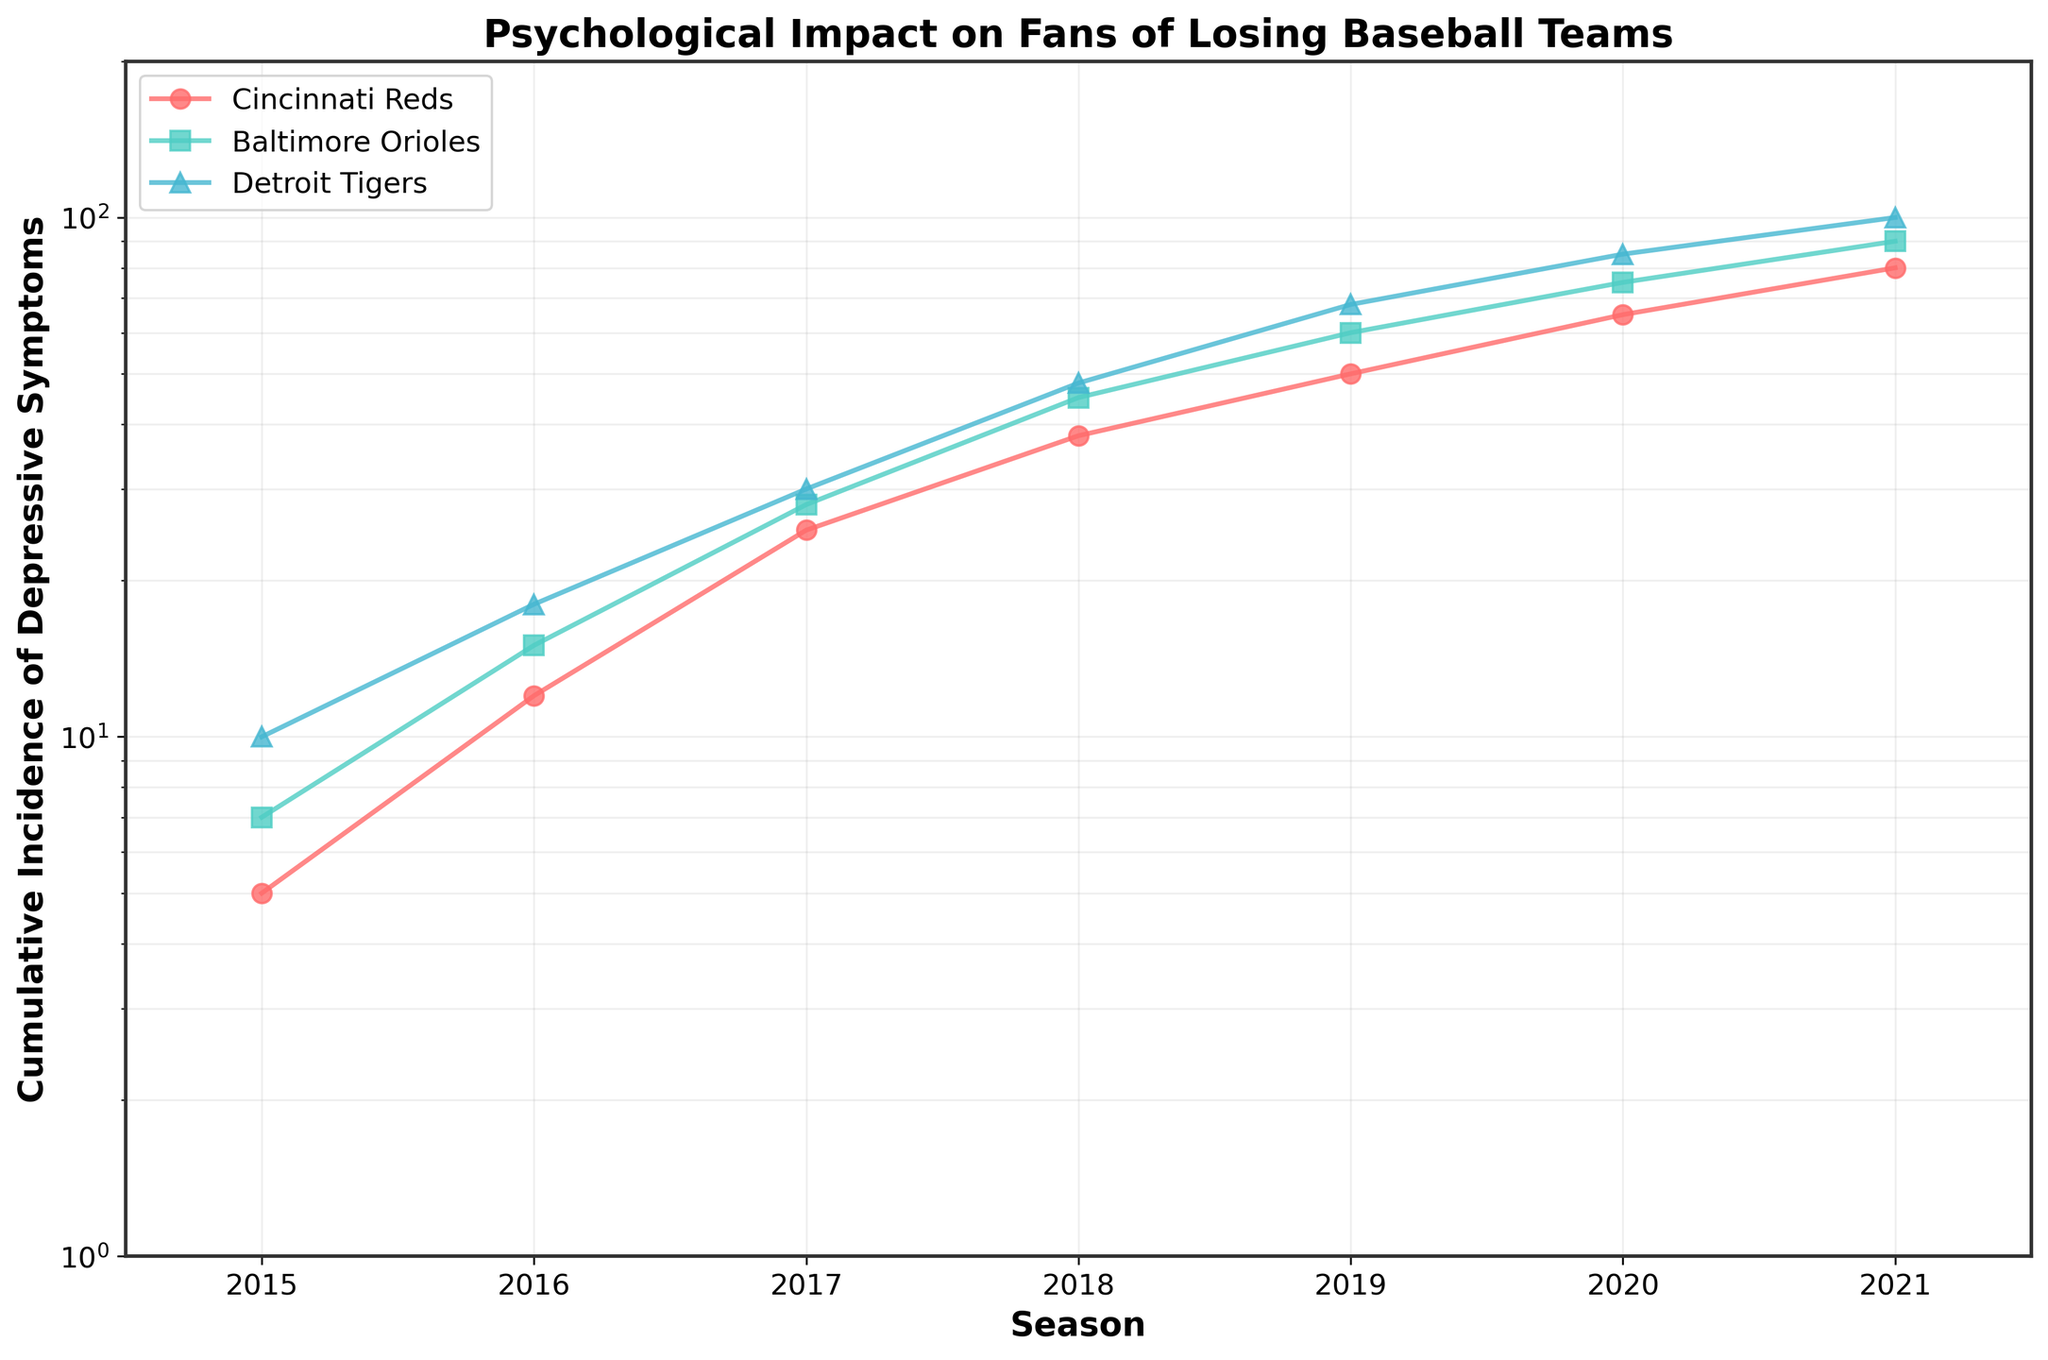What is the title of the plot? The title of the plot is located at the top of the figure, usually in bold fonts. By reading the title, we get the main topic of the plot.
Answer: Psychological Impact on Fans of Losing Baseball Teams Which team had the highest cumulative incidence of depressive symptoms in 2021? By looking at the end of each line for the year 2021 on the x-axis, we can identify which line reaches the highest point on the y-axis.
Answer: Detroit Tigers How does the cumulative incidence of depressive symptoms change for the Cincinnati Reds from 2015 to 2021? By following the line for the Cincinnati Reds from 2015 to 2021, we can observe the general trend; it starts from a lower value and increases steadily each year.
Answer: It increases from 5 to 80 Between which two consecutive seasons did the Baltimore Orioles experience the largest increase in cumulative incidence of depressive symptoms? By examining the points on the line representing the Baltimore Orioles, we can compare the vertical distances between consecutive seasons to find the largest gap.
Answer: Between 2017 and 2018 Which team had a higher cumulative incidence of depressive symptoms in 2019, Baltimore Orioles or Cincinnati Reds? By locating the data points for 2019 for both teams, we can compare their vertical positions on the y-axis.
Answer: Baltimore Orioles How does the cumulative incidence of depressive symptoms in 2021 for the Detroit Tigers compare to the Baltimore Orioles? By comparing the final points of the lines for both teams in 2021, we can see which is higher.
Answer: Detroit Tigers has a higher incidence What is the general trend observed for all teams over the seasons? By observing the slopes of all three lines, we can summarize the common pattern in the data.
Answer: An upward trend is observed for all teams Approximately how many times higher is the cumulative incidence of depressive symptoms for the Baltimore Orioles in 2021 compared to 2015? We can calculate this by dividing the 2021 value by the 2015 value for the Baltimore Orioles.
Answer: About 12.86 times higher (90/7) What is the common range of the y-axis, and why is it designed in this way? By looking at the y-axis labels, we notice the range and the use of a logarithmic scale. This design effectively handles a wide range of data values and makes trends easier to observe.
Answer: The range is from 1 to 200, using a log scale to accommodate different teams' rates effectively 